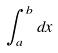Convert formula to latex. <formula><loc_0><loc_0><loc_500><loc_500>\int _ { a } ^ { b } d x</formula> 